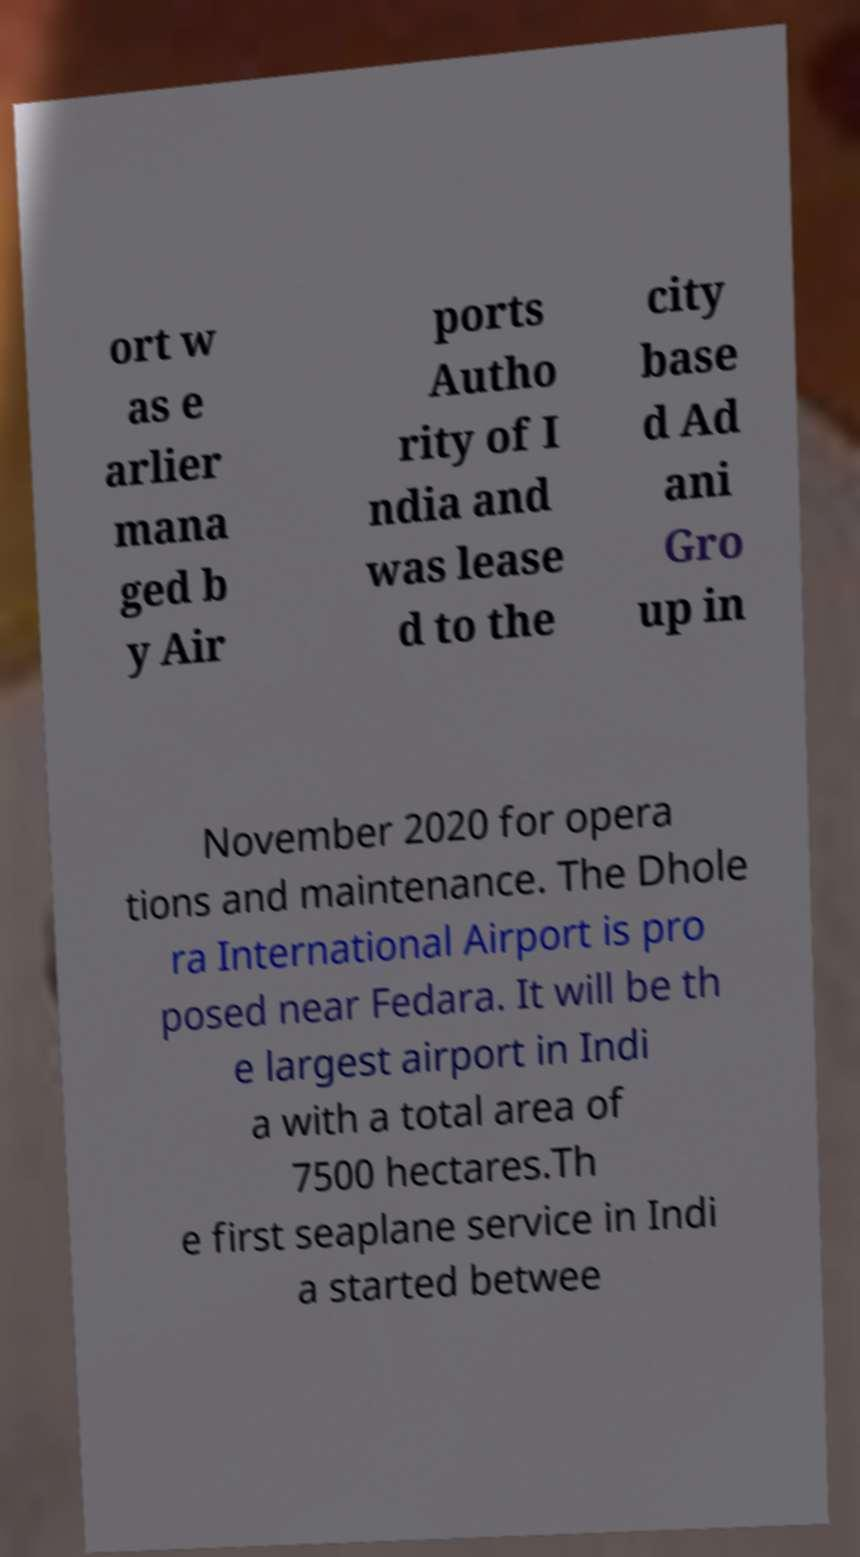For documentation purposes, I need the text within this image transcribed. Could you provide that? ort w as e arlier mana ged b y Air ports Autho rity of I ndia and was lease d to the city base d Ad ani Gro up in November 2020 for opera tions and maintenance. The Dhole ra International Airport is pro posed near Fedara. It will be th e largest airport in Indi a with a total area of 7500 hectares.Th e first seaplane service in Indi a started betwee 